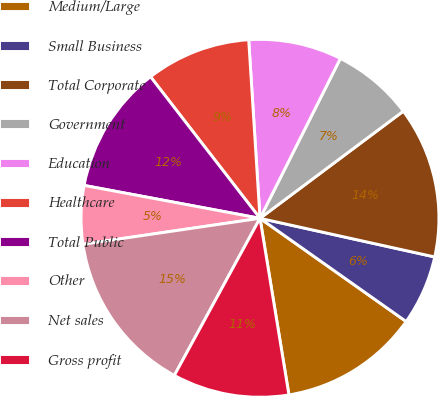Convert chart to OTSL. <chart><loc_0><loc_0><loc_500><loc_500><pie_chart><fcel>Medium/Large<fcel>Small Business<fcel>Total Corporate<fcel>Government<fcel>Education<fcel>Healthcare<fcel>Total Public<fcel>Other<fcel>Net sales<fcel>Gross profit<nl><fcel>12.63%<fcel>6.32%<fcel>13.68%<fcel>7.37%<fcel>8.42%<fcel>9.47%<fcel>11.58%<fcel>5.26%<fcel>14.74%<fcel>10.53%<nl></chart> 